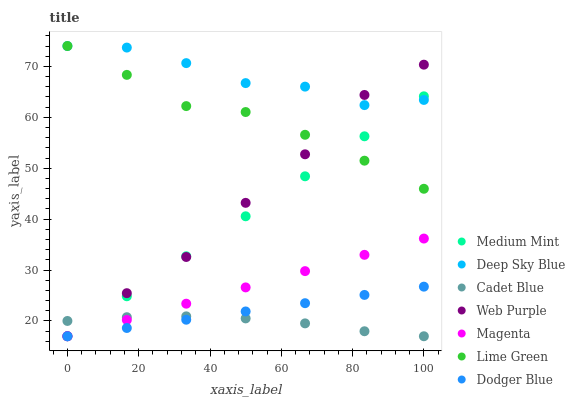Does Cadet Blue have the minimum area under the curve?
Answer yes or no. Yes. Does Deep Sky Blue have the maximum area under the curve?
Answer yes or no. Yes. Does Web Purple have the minimum area under the curve?
Answer yes or no. No. Does Web Purple have the maximum area under the curve?
Answer yes or no. No. Is Dodger Blue the smoothest?
Answer yes or no. Yes. Is Deep Sky Blue the roughest?
Answer yes or no. Yes. Is Cadet Blue the smoothest?
Answer yes or no. No. Is Cadet Blue the roughest?
Answer yes or no. No. Does Medium Mint have the lowest value?
Answer yes or no. Yes. Does Deep Sky Blue have the lowest value?
Answer yes or no. No. Does Lime Green have the highest value?
Answer yes or no. Yes. Does Web Purple have the highest value?
Answer yes or no. No. Is Dodger Blue less than Lime Green?
Answer yes or no. Yes. Is Lime Green greater than Magenta?
Answer yes or no. Yes. Does Magenta intersect Dodger Blue?
Answer yes or no. Yes. Is Magenta less than Dodger Blue?
Answer yes or no. No. Is Magenta greater than Dodger Blue?
Answer yes or no. No. Does Dodger Blue intersect Lime Green?
Answer yes or no. No. 